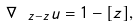<formula> <loc_0><loc_0><loc_500><loc_500>\nabla _ { \ z - z } u = 1 - [ z ] ,</formula> 